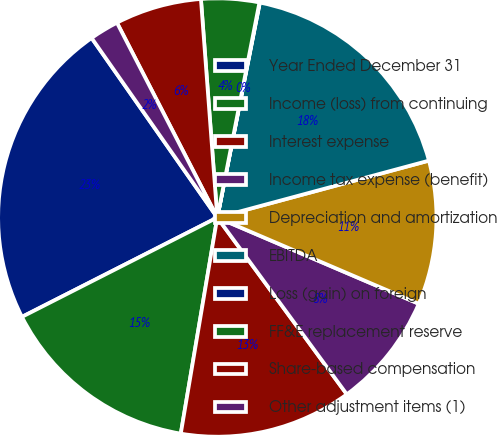Convert chart to OTSL. <chart><loc_0><loc_0><loc_500><loc_500><pie_chart><fcel>Year Ended December 31<fcel>Income (loss) from continuing<fcel>Interest expense<fcel>Income tax expense (benefit)<fcel>Depreciation and amortization<fcel>EBITDA<fcel>Loss (gain) on foreign<fcel>FF&E replacement reserve<fcel>Share-based compensation<fcel>Other adjustment items (1)<nl><fcel>22.77%<fcel>14.85%<fcel>12.73%<fcel>8.5%<fcel>10.62%<fcel>17.71%<fcel>0.03%<fcel>4.27%<fcel>6.38%<fcel>2.15%<nl></chart> 